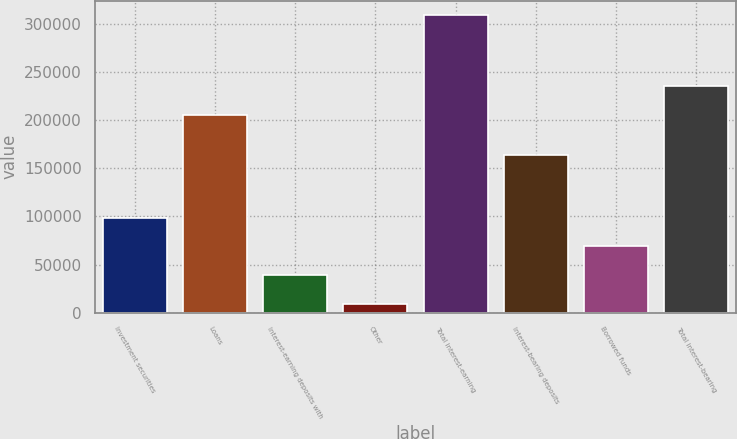Convert chart. <chart><loc_0><loc_0><loc_500><loc_500><bar_chart><fcel>Investment securities<fcel>Loans<fcel>Interest-earning deposits with<fcel>Other<fcel>Total interest-earning<fcel>Interest-bearing deposits<fcel>Borrowed funds<fcel>Total interest-bearing<nl><fcel>98879.6<fcel>205349<fcel>38895.2<fcel>8903<fcel>308825<fcel>163965<fcel>68887.4<fcel>235341<nl></chart> 